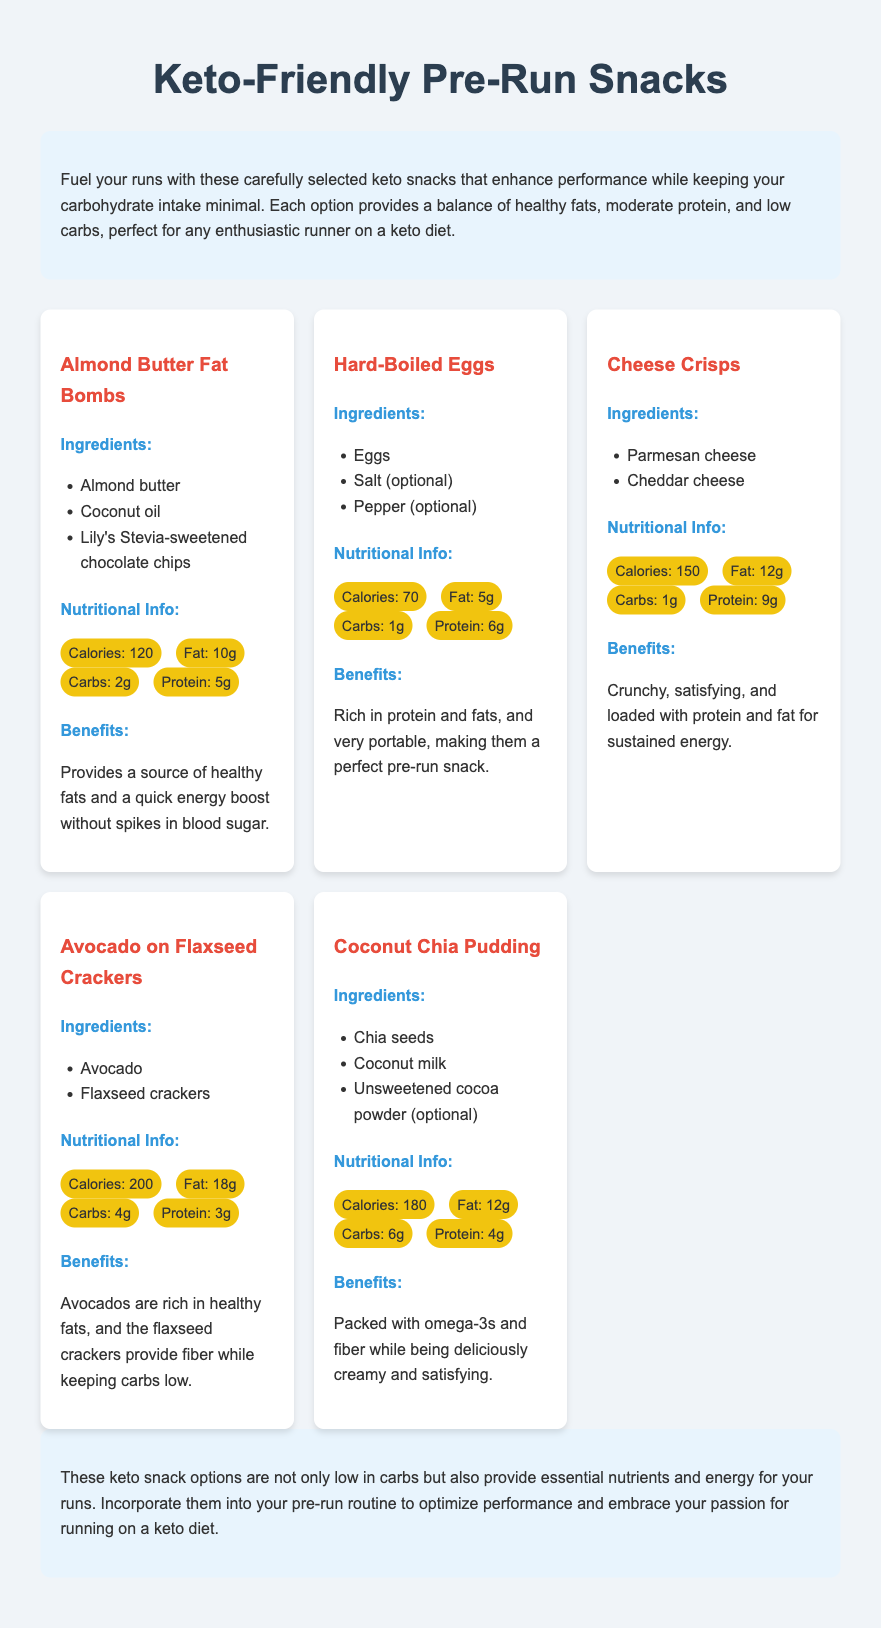What is the calorie count of Almond Butter Fat Bombs? The calorie count is listed under the nutritional info for Almond Butter Fat Bombs, which is 120 calories.
Answer: 120 calories How much fat do Hard-Boiled Eggs contain? The amount of fat is specified in the nutritional info for Hard-Boiled Eggs, which is 5g.
Answer: 5g Which snack has the highest protein content? The protein content can be compared among all snacks, and Cheese Crisps have the highest protein content at 9g.
Answer: Cheese Crisps What are the main ingredients in Coconut Chia Pudding? The ingredients for Coconut Chia Pudding are explicitly listed as chia seeds, coconut milk, and unsweetened cocoa powder (optional).
Answer: Chia seeds, coconut milk, unsweetened cocoa powder How many grams of carbs are in Avocado on Flaxseed Crackers? The carbohydrate content is provided in the nutritional info for Avocado on Flaxseed Crackers, which shows it contains 4g.
Answer: 4g What benefits do Cheese Crisps provide? The benefits are described in the benefits section for Cheese Crisps, stating they are crunchy and loaded with protein and fat for sustained energy.
Answer: Crunchy, loaded with protein and fat What is a quick source of energy mentioned for Almond Butter Fat Bombs? The benefits section mentions that Almond Butter Fat Bombs provide a quick energy boost without spikes in blood sugar.
Answer: Quick energy boost What type of dietary approach is this menu supporting? The introduction states that the snacks are tailored for those following a keto diet, emphasizing the low-carb aspect.
Answer: Keto diet 